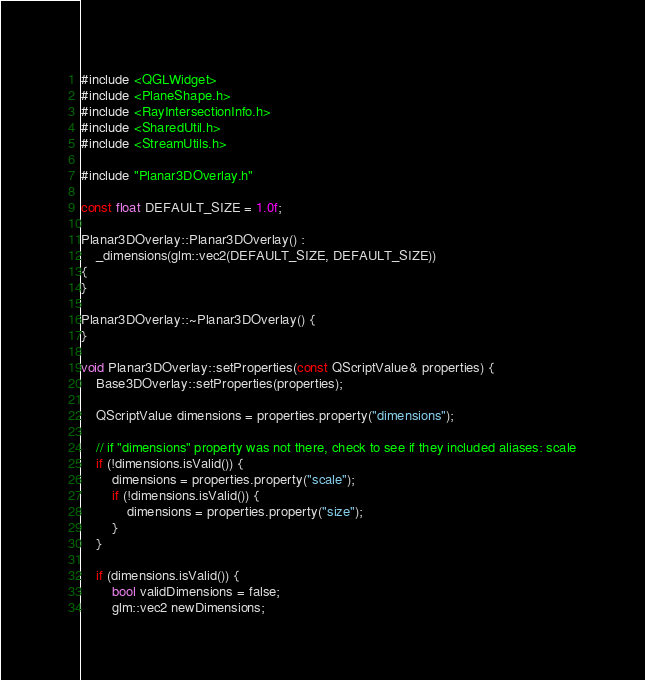Convert code to text. <code><loc_0><loc_0><loc_500><loc_500><_C++_>
#include <QGLWidget>
#include <PlaneShape.h>
#include <RayIntersectionInfo.h>
#include <SharedUtil.h>
#include <StreamUtils.h>

#include "Planar3DOverlay.h"

const float DEFAULT_SIZE = 1.0f;

Planar3DOverlay::Planar3DOverlay() :
    _dimensions(glm::vec2(DEFAULT_SIZE, DEFAULT_SIZE))
{
}

Planar3DOverlay::~Planar3DOverlay() {
}

void Planar3DOverlay::setProperties(const QScriptValue& properties) {
    Base3DOverlay::setProperties(properties);

    QScriptValue dimensions = properties.property("dimensions");

    // if "dimensions" property was not there, check to see if they included aliases: scale
    if (!dimensions.isValid()) {
        dimensions = properties.property("scale");
        if (!dimensions.isValid()) {
            dimensions = properties.property("size");
        }
    }

    if (dimensions.isValid()) {
        bool validDimensions = false;
        glm::vec2 newDimensions;
</code> 